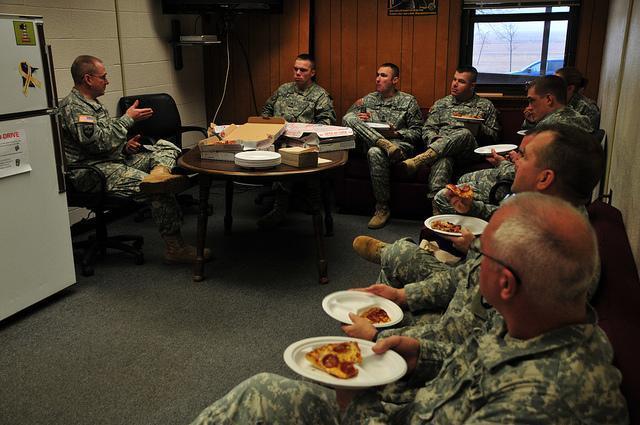How many women in the room?
Give a very brief answer. 0. How many children are in the photo?
Give a very brief answer. 0. How many people are visible?
Give a very brief answer. 7. How many chairs can be seen?
Give a very brief answer. 3. How many different kinds of apples are there?
Give a very brief answer. 0. 